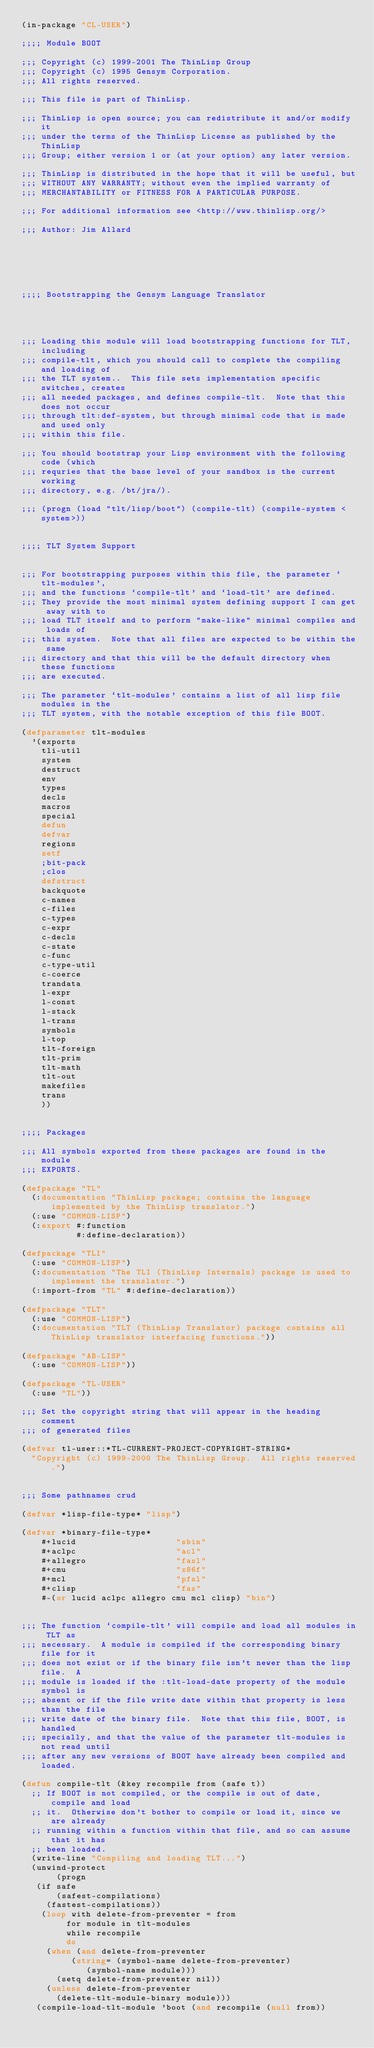Convert code to text. <code><loc_0><loc_0><loc_500><loc_500><_Lisp_>(in-package "CL-USER")

;;;; Module BOOT

;;; Copyright (c) 1999-2001 The ThinLisp Group
;;; Copyright (c) 1995 Gensym Corporation.
;;; All rights reserved.

;;; This file is part of ThinLisp.

;;; ThinLisp is open source; you can redistribute it and/or modify it
;;; under the terms of the ThinLisp License as published by the ThinLisp
;;; Group; either version 1 or (at your option) any later version.

;;; ThinLisp is distributed in the hope that it will be useful, but
;;; WITHOUT ANY WARRANTY; without even the implied warranty of
;;; MERCHANTABILITY or FITNESS FOR A PARTICULAR PURPOSE.

;;; For additional information see <http://www.thinlisp.org/>

;;; Author: Jim Allard






;;;; Bootstrapping the Gensym Language Translator




;;; Loading this module will load bootstrapping functions for TLT, including
;;; compile-tlt, which you should call to complete the compiling and loading of
;;; the TLT system..  This file sets implementation specific switches, creates
;;; all needed packages, and defines compile-tlt.  Note that this does not occur
;;; through tlt:def-system, but through minimal code that is made and used only
;;; within this file.

;;; You should bootstrap your Lisp environment with the following code (which
;;; requries that the base level of your sandbox is the current working
;;; directory, e.g. /bt/jra/).

;;; (progn (load "tlt/lisp/boot") (compile-tlt) (compile-system <system>))


;;;; TLT System Support


;;; For bootstrapping purposes within this file, the parameter `tlt-modules',
;;; and the functions `compile-tlt' and `load-tlt' are defined.
;;; They provide the most minimal system defining support I can get away with to
;;; load TLT itself and to perform "make-like" minimal compiles and loads of
;;; this system.  Note that all files are expected to be within the same
;;; directory and that this will be the default directory when these functions
;;; are executed.

;;; The parameter `tlt-modules' contains a list of all lisp file modules in the
;;; TLT system, with the notable exception of this file BOOT.

(defparameter tlt-modules
  '(exports
    tli-util
    system
    destruct
    env
    types
    decls
    macros
    special
    defun
    defvar
    regions
    setf
    ;bit-pack
    ;clos
    defstruct
    backquote
    c-names
    c-files
    c-types
    c-expr
    c-decls
    c-state
    c-func
    c-type-util
    c-coerce
    trandata
    l-expr
    l-const
    l-stack
    l-trans
    symbols
    l-top
    tlt-foreign
    tlt-prim
    tlt-math
    tlt-out
    makefiles
    trans
    ))


;;;; Packages

;;; All symbols exported from these packages are found in the module
;;; EXPORTS.

(defpackage "TL"
  (:documentation "ThinLisp package; contains the language implemented by the ThinLisp translator.")
  (:use "COMMON-LISP")
  (:export #:function
           #:define-declaration))

(defpackage "TLI"
  (:use "COMMON-LISP")
  (:documentation "The TLI (ThinLisp Internals) package is used to implement the translator.")
  (:import-from "TL" #:define-declaration))

(defpackage "TLT"
  (:use "COMMON-LISP")
  (:documentation "TLT (ThinLisp Translator) package contains all ThinLisp translator interfacing functions."))

(defpackage "AB-LISP"
  (:use "COMMON-LISP"))

(defpackage "TL-USER"
  (:use "TL"))

;;; Set the copyright string that will appear in the heading comment
;;; of generated files

(defvar tl-user::*TL-CURRENT-PROJECT-COPYRIGHT-STRING*
  "Copyright (c) 1999-2000 The ThinLisp Group.  All rights reserved.")


;;; Some pathnames crud

(defvar *lisp-file-type* "lisp")

(defvar *binary-file-type* 
    #+lucid                    "sbin"
    #+aclpc                    "acl"
    #+allegro                  "fasl"
    #+cmu                      "x86f"
    #+mcl                      "pfsl"
    #+clisp                    "fas"
    #-(or lucid aclpc allegro cmu mcl clisp) "bin")


;;; The function `compile-tlt' will compile and load all modules in TLT as
;;; necessary.  A module is compiled if the corresponding binary file for it
;;; does not exist or if the binary file isn't newer than the lisp file.  A
;;; module is loaded if the :tlt-load-date property of the module symbol is
;;; absent or if the file write date within that property is less than the file
;;; write date of the binary file.  Note that this file, BOOT, is handled
;;; specially, and that the value of the parameter tlt-modules is not read until
;;; after any new versions of BOOT have already been compiled and loaded.

(defun compile-tlt (&key recompile from (safe t))
  ;; If BOOT is not compiled, or the compile is out of date, compile and load
  ;; it.  Otherwise don't bother to compile or load it, since we are already
  ;; running within a function within that file, and so can assume that it has
  ;; been loaded.
  (write-line "Compiling and loading TLT...")
  (unwind-protect
       (progn
	 (if safe
	     (safest-compilations)
	   (fastest-compilations))
	  (loop with delete-from-preventer = from
 	       for module in tlt-modules 
 	       while recompile
 	       do
 	   (when (and delete-from-preventer
 		      (string= (symbol-name delete-from-preventer) 
 			       (symbol-name module)))
 	     (setq delete-from-preventer nil))
 	   (unless delete-from-preventer
 	     (delete-tlt-module-binary module)))
	 (compile-load-tlt-module 'boot (and recompile (null from)) </code> 